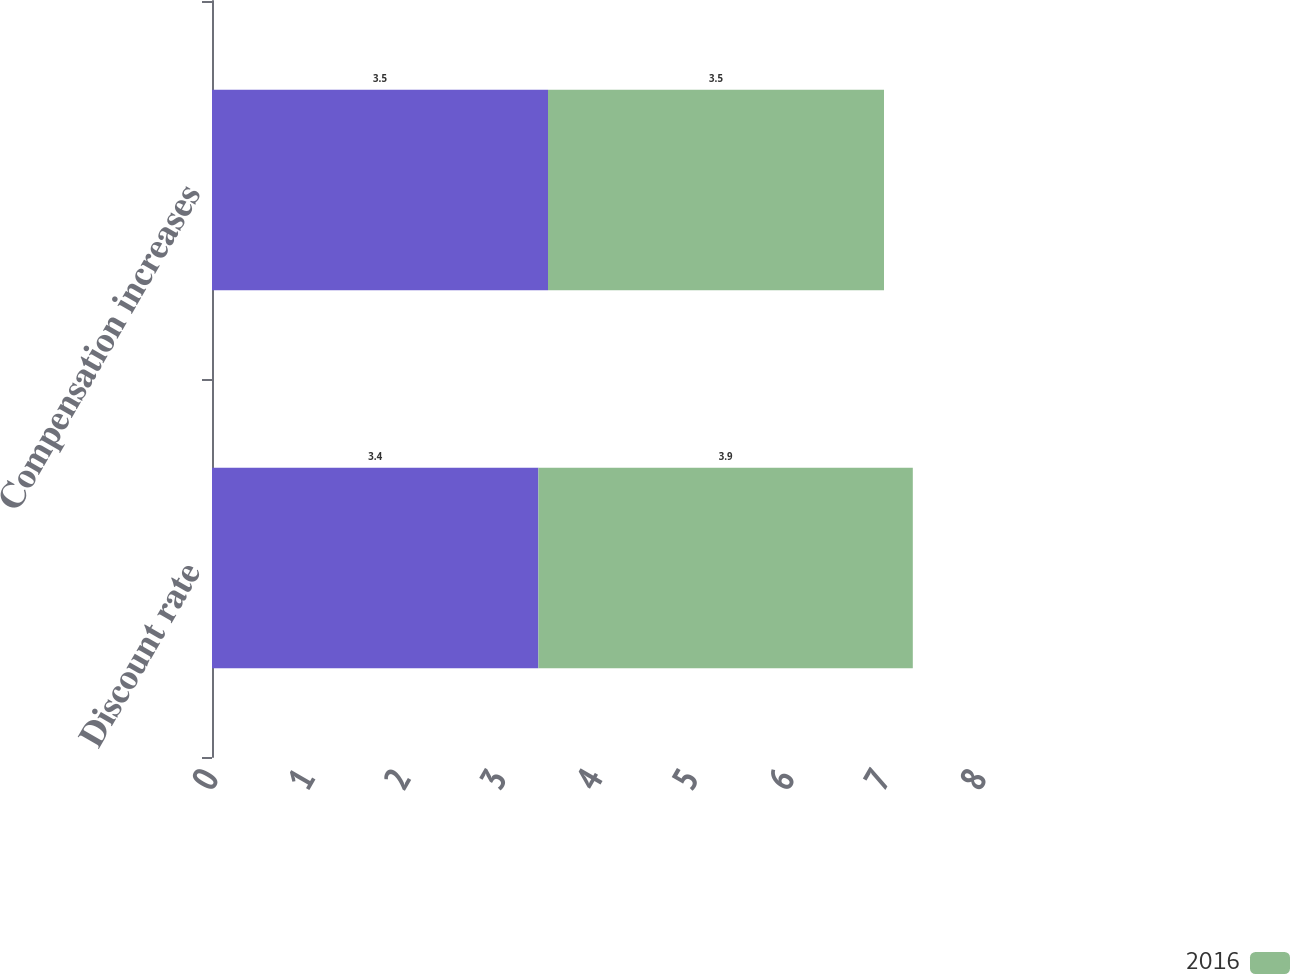<chart> <loc_0><loc_0><loc_500><loc_500><stacked_bar_chart><ecel><fcel>Discount rate<fcel>Compensation increases<nl><fcel>nan<fcel>3.4<fcel>3.5<nl><fcel>2016<fcel>3.9<fcel>3.5<nl></chart> 